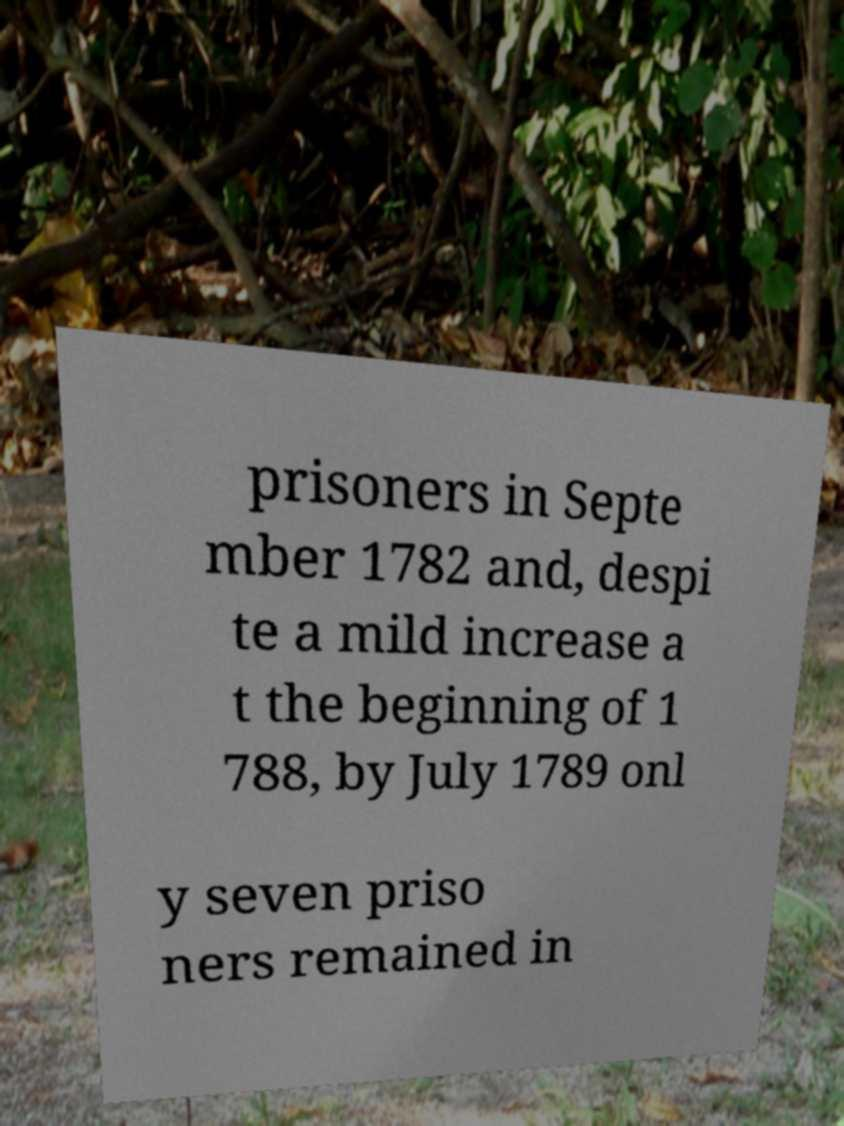What messages or text are displayed in this image? I need them in a readable, typed format. prisoners in Septe mber 1782 and, despi te a mild increase a t the beginning of 1 788, by July 1789 onl y seven priso ners remained in 